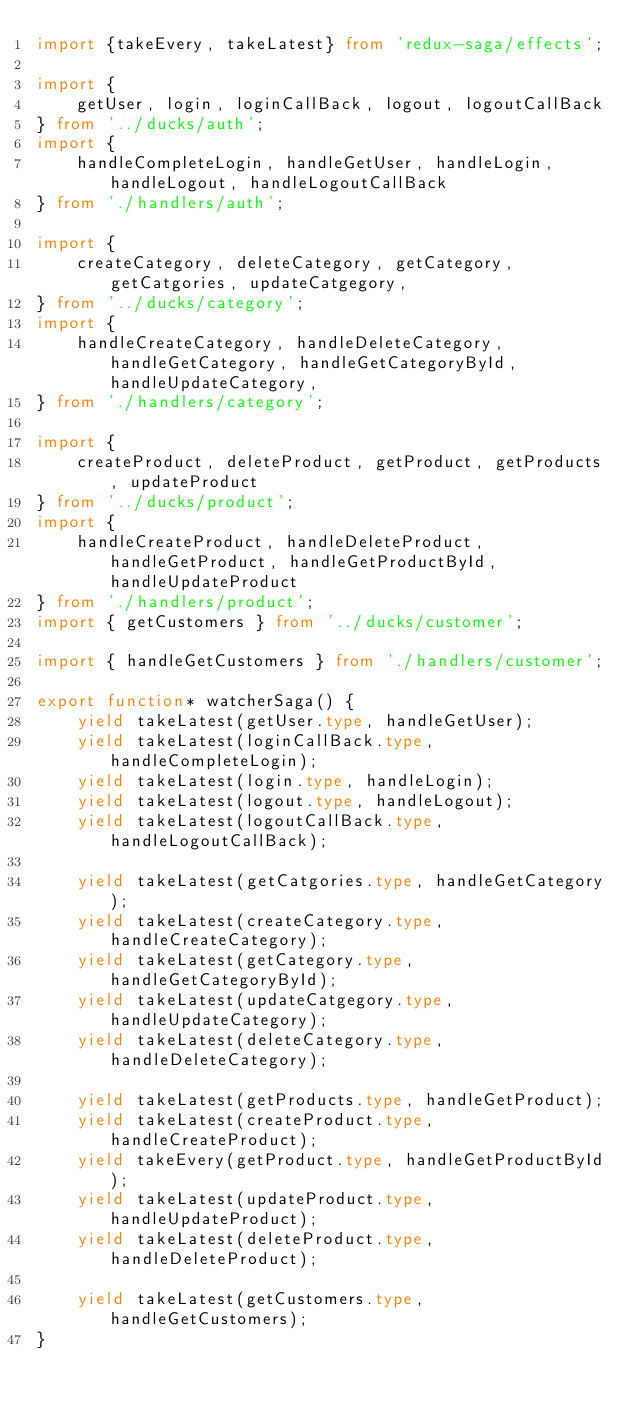Convert code to text. <code><loc_0><loc_0><loc_500><loc_500><_TypeScript_>import {takeEvery, takeLatest} from 'redux-saga/effects';

import { 
    getUser, login, loginCallBack, logout, logoutCallBack
} from '../ducks/auth';
import { 
    handleCompleteLogin, handleGetUser, handleLogin, handleLogout, handleLogoutCallBack 
} from './handlers/auth';

import { 
    createCategory, deleteCategory, getCategory, getCatgories, updateCatgegory,
} from '../ducks/category';
import { 
    handleCreateCategory, handleDeleteCategory, handleGetCategory, handleGetCategoryById, handleUpdateCategory,
} from './handlers/category';

import { 
    createProduct, deleteProduct, getProduct, getProducts, updateProduct
} from '../ducks/product';
import { 
    handleCreateProduct, handleDeleteProduct, handleGetProduct, handleGetProductById, handleUpdateProduct
} from './handlers/product';
import { getCustomers } from '../ducks/customer';

import { handleGetCustomers } from './handlers/customer';

export function* watcherSaga() {
    yield takeLatest(getUser.type, handleGetUser);
    yield takeLatest(loginCallBack.type, handleCompleteLogin);
    yield takeLatest(login.type, handleLogin);
    yield takeLatest(logout.type, handleLogout);
    yield takeLatest(logoutCallBack.type, handleLogoutCallBack);

    yield takeLatest(getCatgories.type, handleGetCategory);
    yield takeLatest(createCategory.type, handleCreateCategory);
    yield takeLatest(getCategory.type, handleGetCategoryById);
    yield takeLatest(updateCatgegory.type, handleUpdateCategory);
    yield takeLatest(deleteCategory.type, handleDeleteCategory);

    yield takeLatest(getProducts.type, handleGetProduct);
    yield takeLatest(createProduct.type, handleCreateProduct);
    yield takeEvery(getProduct.type, handleGetProductById);
    yield takeLatest(updateProduct.type, handleUpdateProduct);
    yield takeLatest(deleteProduct.type, handleDeleteProduct);

    yield takeLatest(getCustomers.type, handleGetCustomers);
}</code> 